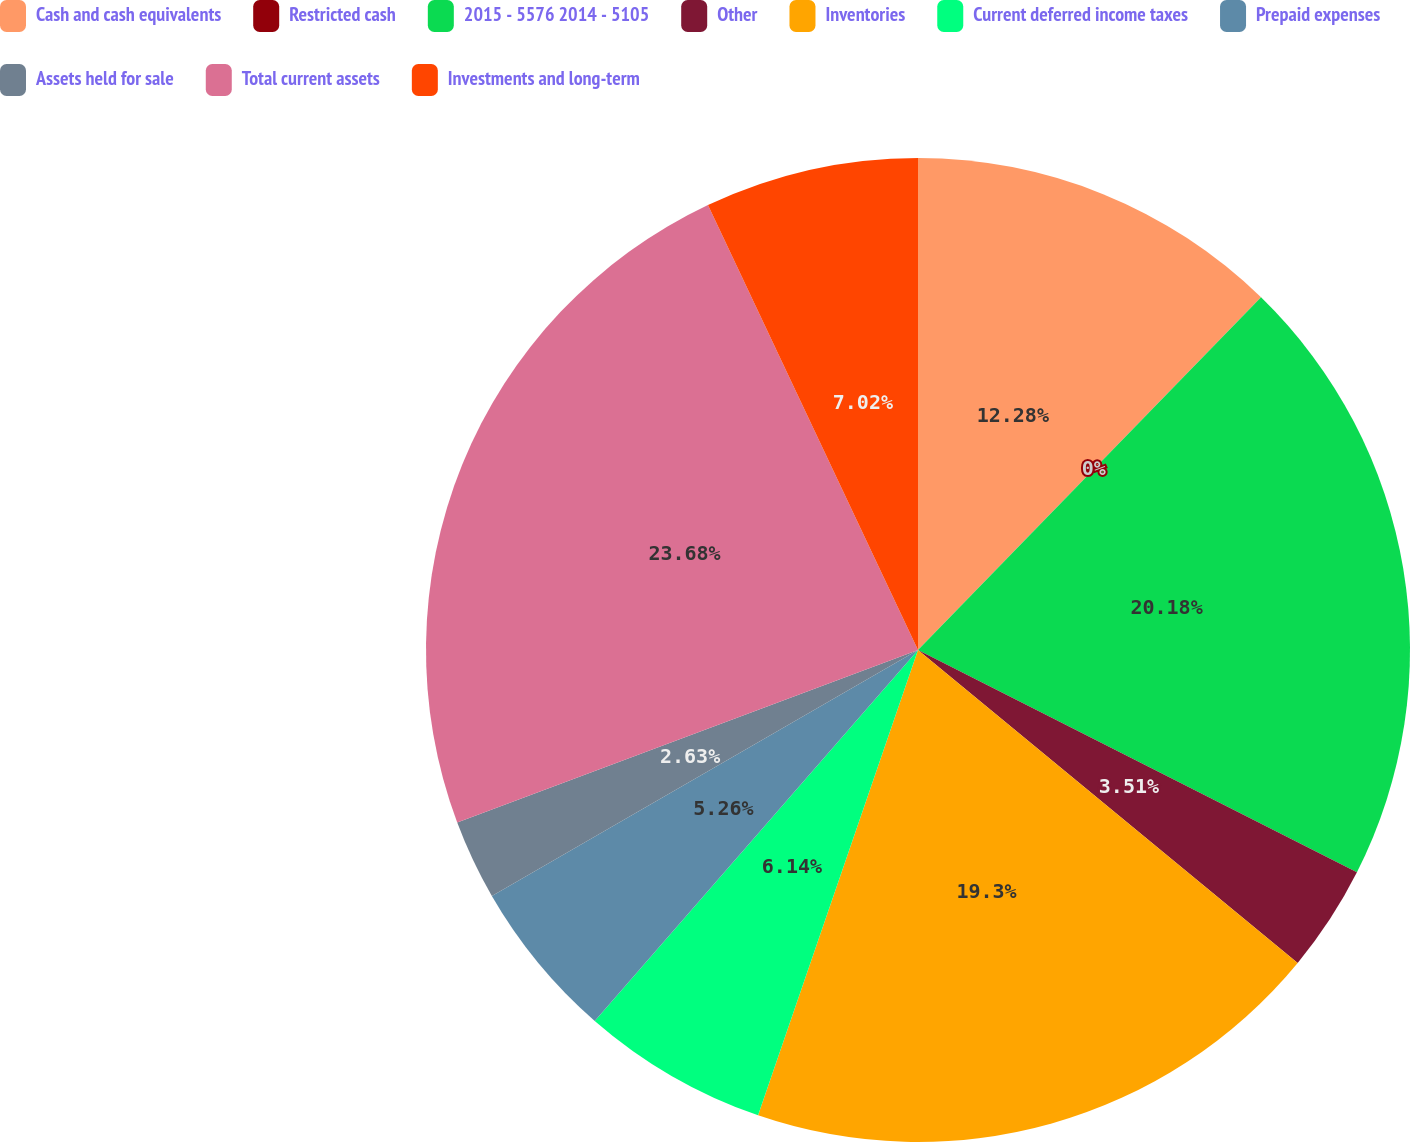Convert chart to OTSL. <chart><loc_0><loc_0><loc_500><loc_500><pie_chart><fcel>Cash and cash equivalents<fcel>Restricted cash<fcel>2015 - 5576 2014 - 5105<fcel>Other<fcel>Inventories<fcel>Current deferred income taxes<fcel>Prepaid expenses<fcel>Assets held for sale<fcel>Total current assets<fcel>Investments and long-term<nl><fcel>12.28%<fcel>0.0%<fcel>20.18%<fcel>3.51%<fcel>19.3%<fcel>6.14%<fcel>5.26%<fcel>2.63%<fcel>23.68%<fcel>7.02%<nl></chart> 